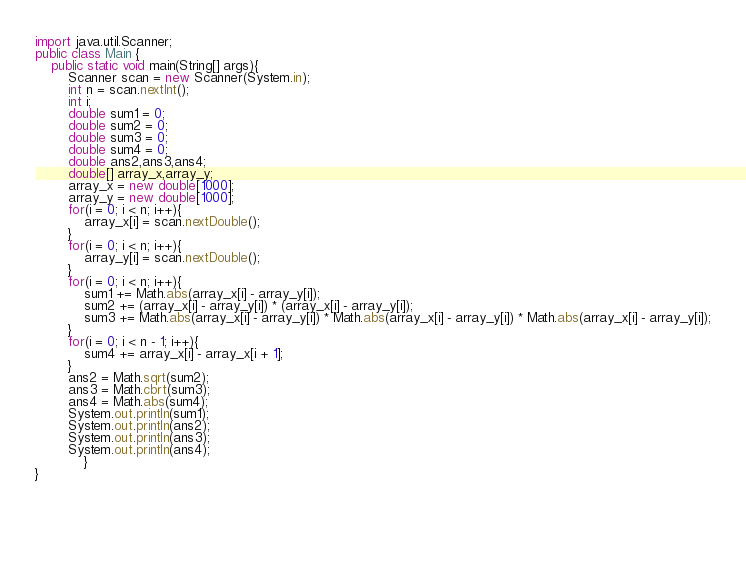Convert code to text. <code><loc_0><loc_0><loc_500><loc_500><_Java_>import java.util.Scanner;
public class Main {
    public static void main(String[] args){
        Scanner scan = new Scanner(System.in);
        int n = scan.nextInt();
        int i;
        double sum1 = 0;
        double sum2 = 0;
        double sum3 = 0;
        double sum4 = 0;
        double ans2,ans3,ans4;
        double[] array_x,array_y;
        array_x = new double[1000];
        array_y = new double[1000];
        for(i = 0; i < n; i++){
        	array_x[i] = scan.nextDouble();
        }
        for(i = 0; i < n; i++){
        	array_y[i] = scan.nextDouble();
        }
        for(i = 0; i < n; i++){
        	sum1 += Math.abs(array_x[i] - array_y[i]);
        	sum2 += (array_x[i] - array_y[i]) * (array_x[i] - array_y[i]);
        	sum3 += Math.abs(array_x[i] - array_y[i]) * Math.abs(array_x[i] - array_y[i]) * Math.abs(array_x[i] - array_y[i]);
        }
        for(i = 0; i < n - 1; i++){
        	sum4 += array_x[i] - array_x[i + 1];
        }
        ans2 = Math.sqrt(sum2);
        ans3 = Math.cbrt(sum3);
        ans4 = Math.abs(sum4);
        System.out.println(sum1);
        System.out.println(ans2);
        System.out.println(ans3);
        System.out.println(ans4);
            }
}



		

	</code> 